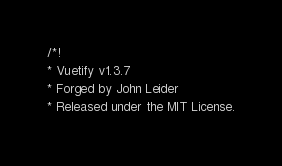<code> <loc_0><loc_0><loc_500><loc_500><_CSS_>/*!
* Vuetify v1.3.7
* Forged by John Leider
* Released under the MIT License.</code> 